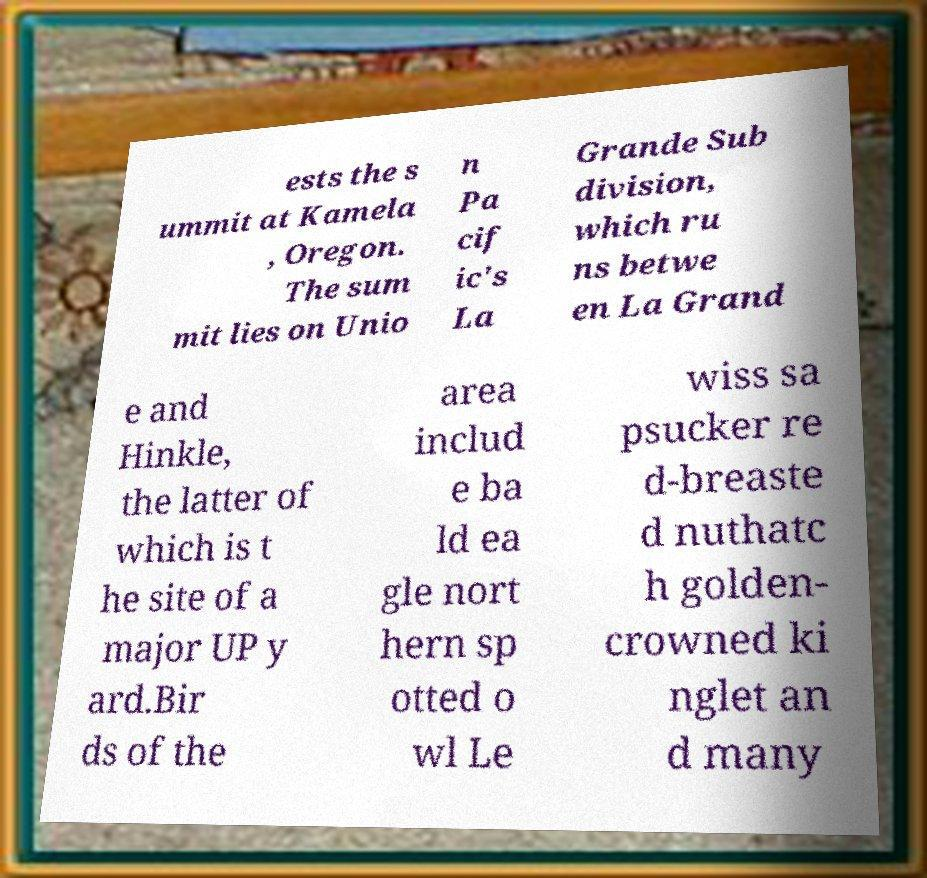Please identify and transcribe the text found in this image. ests the s ummit at Kamela , Oregon. The sum mit lies on Unio n Pa cif ic's La Grande Sub division, which ru ns betwe en La Grand e and Hinkle, the latter of which is t he site of a major UP y ard.Bir ds of the area includ e ba ld ea gle nort hern sp otted o wl Le wiss sa psucker re d-breaste d nuthatc h golden- crowned ki nglet an d many 